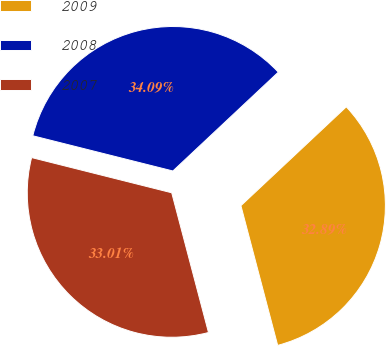<chart> <loc_0><loc_0><loc_500><loc_500><pie_chart><fcel>2009<fcel>2008<fcel>2007<nl><fcel>32.89%<fcel>34.09%<fcel>33.01%<nl></chart> 